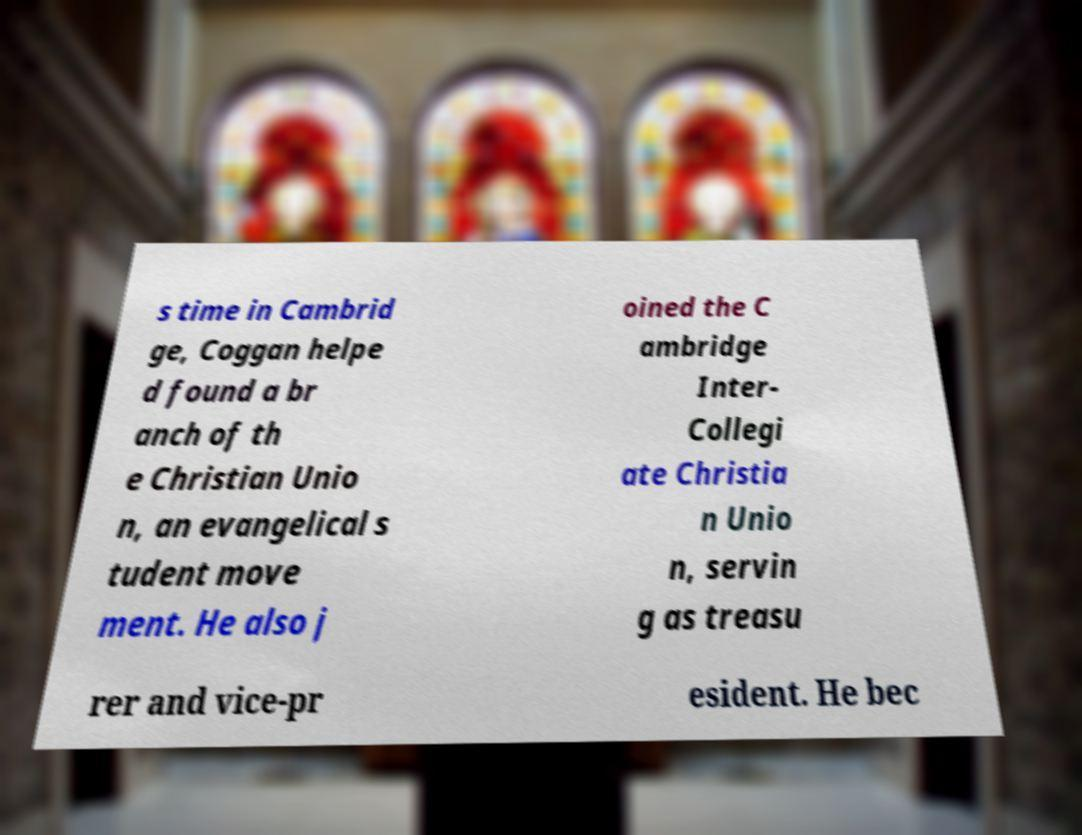Could you extract and type out the text from this image? s time in Cambrid ge, Coggan helpe d found a br anch of th e Christian Unio n, an evangelical s tudent move ment. He also j oined the C ambridge Inter- Collegi ate Christia n Unio n, servin g as treasu rer and vice-pr esident. He bec 